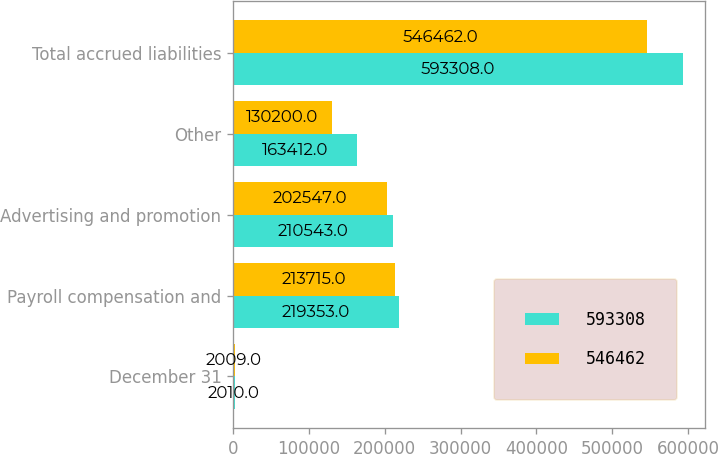Convert chart. <chart><loc_0><loc_0><loc_500><loc_500><stacked_bar_chart><ecel><fcel>December 31<fcel>Payroll compensation and<fcel>Advertising and promotion<fcel>Other<fcel>Total accrued liabilities<nl><fcel>593308<fcel>2010<fcel>219353<fcel>210543<fcel>163412<fcel>593308<nl><fcel>546462<fcel>2009<fcel>213715<fcel>202547<fcel>130200<fcel>546462<nl></chart> 